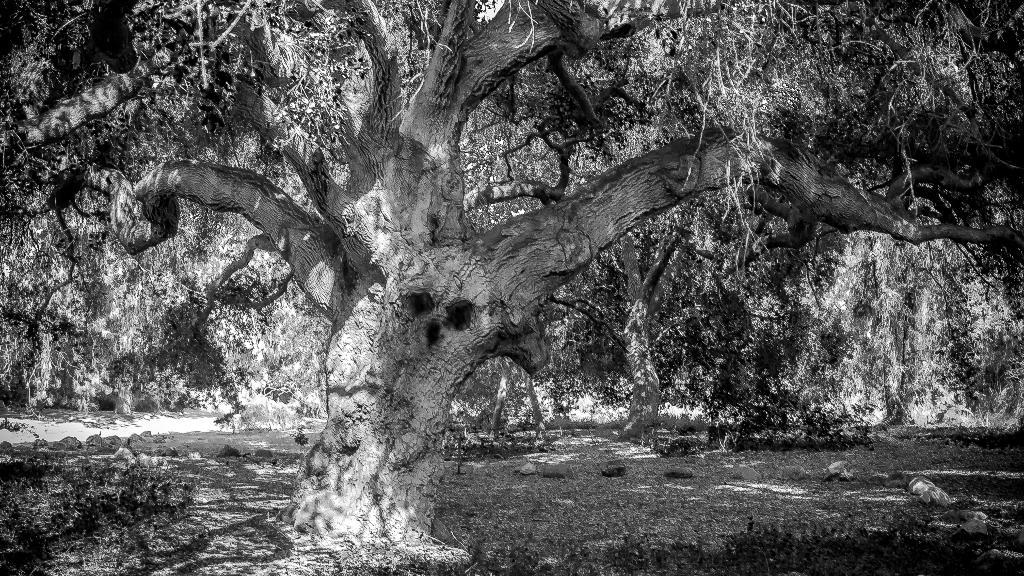What is the color scheme of the image? The image is black and white. What type of natural elements can be seen in the image? There are trees in the image. What is the state of the trees in the image? The trees have leaves. What type of face can be seen on the tree in the image? There is no face present on the trees in the image; they are depicted as natural elements with leaves. 